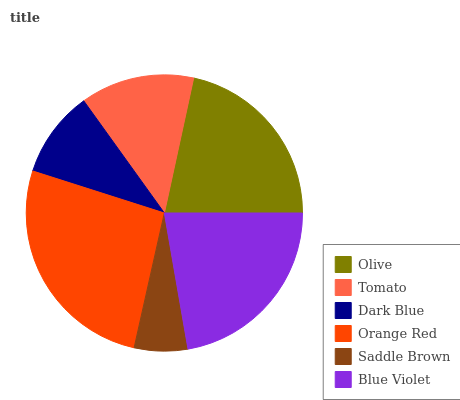Is Saddle Brown the minimum?
Answer yes or no. Yes. Is Orange Red the maximum?
Answer yes or no. Yes. Is Tomato the minimum?
Answer yes or no. No. Is Tomato the maximum?
Answer yes or no. No. Is Olive greater than Tomato?
Answer yes or no. Yes. Is Tomato less than Olive?
Answer yes or no. Yes. Is Tomato greater than Olive?
Answer yes or no. No. Is Olive less than Tomato?
Answer yes or no. No. Is Olive the high median?
Answer yes or no. Yes. Is Tomato the low median?
Answer yes or no. Yes. Is Tomato the high median?
Answer yes or no. No. Is Orange Red the low median?
Answer yes or no. No. 